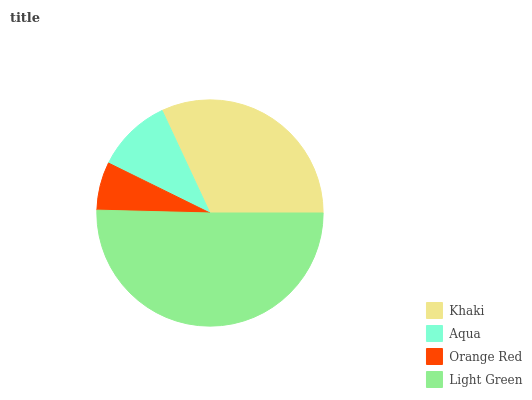Is Orange Red the minimum?
Answer yes or no. Yes. Is Light Green the maximum?
Answer yes or no. Yes. Is Aqua the minimum?
Answer yes or no. No. Is Aqua the maximum?
Answer yes or no. No. Is Khaki greater than Aqua?
Answer yes or no. Yes. Is Aqua less than Khaki?
Answer yes or no. Yes. Is Aqua greater than Khaki?
Answer yes or no. No. Is Khaki less than Aqua?
Answer yes or no. No. Is Khaki the high median?
Answer yes or no. Yes. Is Aqua the low median?
Answer yes or no. Yes. Is Aqua the high median?
Answer yes or no. No. Is Light Green the low median?
Answer yes or no. No. 